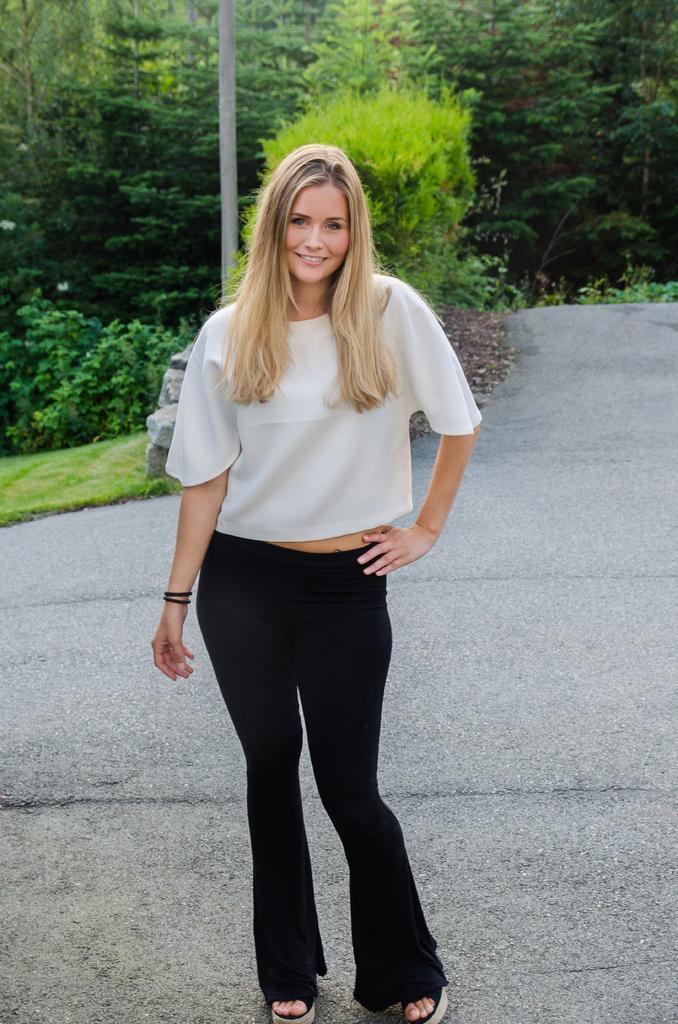Can you describe this image briefly? In this picture we can see a woman on the ground and she is smiling and in the background we can see a pole, few stones and trees. 